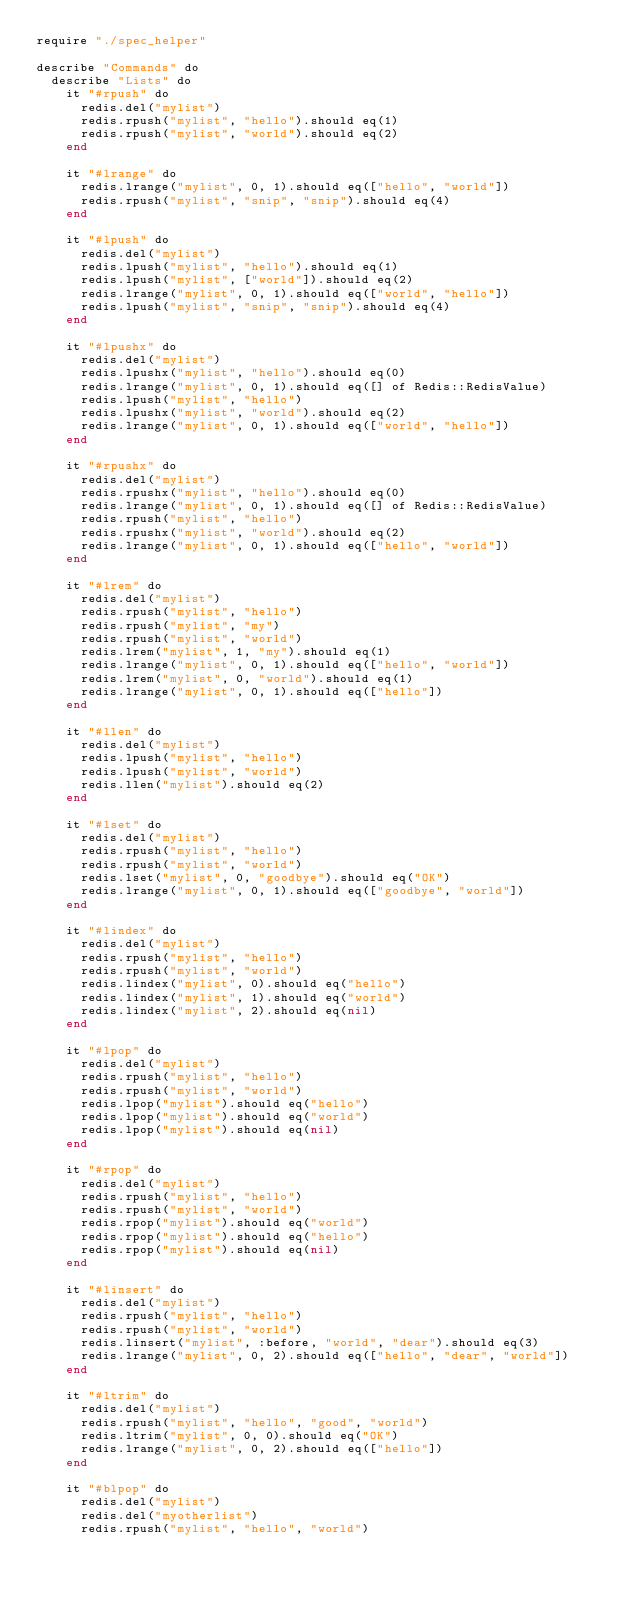Convert code to text. <code><loc_0><loc_0><loc_500><loc_500><_Crystal_>require "./spec_helper"

describe "Commands" do
  describe "Lists" do
    it "#rpush" do
      redis.del("mylist")
      redis.rpush("mylist", "hello").should eq(1)
      redis.rpush("mylist", "world").should eq(2)
    end

    it "#lrange" do
      redis.lrange("mylist", 0, 1).should eq(["hello", "world"])
      redis.rpush("mylist", "snip", "snip").should eq(4)
    end

    it "#lpush" do
      redis.del("mylist")
      redis.lpush("mylist", "hello").should eq(1)
      redis.lpush("mylist", ["world"]).should eq(2)
      redis.lrange("mylist", 0, 1).should eq(["world", "hello"])
      redis.lpush("mylist", "snip", "snip").should eq(4)
    end

    it "#lpushx" do
      redis.del("mylist")
      redis.lpushx("mylist", "hello").should eq(0)
      redis.lrange("mylist", 0, 1).should eq([] of Redis::RedisValue)
      redis.lpush("mylist", "hello")
      redis.lpushx("mylist", "world").should eq(2)
      redis.lrange("mylist", 0, 1).should eq(["world", "hello"])
    end

    it "#rpushx" do
      redis.del("mylist")
      redis.rpushx("mylist", "hello").should eq(0)
      redis.lrange("mylist", 0, 1).should eq([] of Redis::RedisValue)
      redis.rpush("mylist", "hello")
      redis.rpushx("mylist", "world").should eq(2)
      redis.lrange("mylist", 0, 1).should eq(["hello", "world"])
    end

    it "#lrem" do
      redis.del("mylist")
      redis.rpush("mylist", "hello")
      redis.rpush("mylist", "my")
      redis.rpush("mylist", "world")
      redis.lrem("mylist", 1, "my").should eq(1)
      redis.lrange("mylist", 0, 1).should eq(["hello", "world"])
      redis.lrem("mylist", 0, "world").should eq(1)
      redis.lrange("mylist", 0, 1).should eq(["hello"])
    end

    it "#llen" do
      redis.del("mylist")
      redis.lpush("mylist", "hello")
      redis.lpush("mylist", "world")
      redis.llen("mylist").should eq(2)
    end

    it "#lset" do
      redis.del("mylist")
      redis.rpush("mylist", "hello")
      redis.rpush("mylist", "world")
      redis.lset("mylist", 0, "goodbye").should eq("OK")
      redis.lrange("mylist", 0, 1).should eq(["goodbye", "world"])
    end

    it "#lindex" do
      redis.del("mylist")
      redis.rpush("mylist", "hello")
      redis.rpush("mylist", "world")
      redis.lindex("mylist", 0).should eq("hello")
      redis.lindex("mylist", 1).should eq("world")
      redis.lindex("mylist", 2).should eq(nil)
    end

    it "#lpop" do
      redis.del("mylist")
      redis.rpush("mylist", "hello")
      redis.rpush("mylist", "world")
      redis.lpop("mylist").should eq("hello")
      redis.lpop("mylist").should eq("world")
      redis.lpop("mylist").should eq(nil)
    end

    it "#rpop" do
      redis.del("mylist")
      redis.rpush("mylist", "hello")
      redis.rpush("mylist", "world")
      redis.rpop("mylist").should eq("world")
      redis.rpop("mylist").should eq("hello")
      redis.rpop("mylist").should eq(nil)
    end

    it "#linsert" do
      redis.del("mylist")
      redis.rpush("mylist", "hello")
      redis.rpush("mylist", "world")
      redis.linsert("mylist", :before, "world", "dear").should eq(3)
      redis.lrange("mylist", 0, 2).should eq(["hello", "dear", "world"])
    end

    it "#ltrim" do
      redis.del("mylist")
      redis.rpush("mylist", "hello", "good", "world")
      redis.ltrim("mylist", 0, 0).should eq("OK")
      redis.lrange("mylist", 0, 2).should eq(["hello"])
    end

    it "#blpop" do
      redis.del("mylist")
      redis.del("myotherlist")
      redis.rpush("mylist", "hello", "world")</code> 